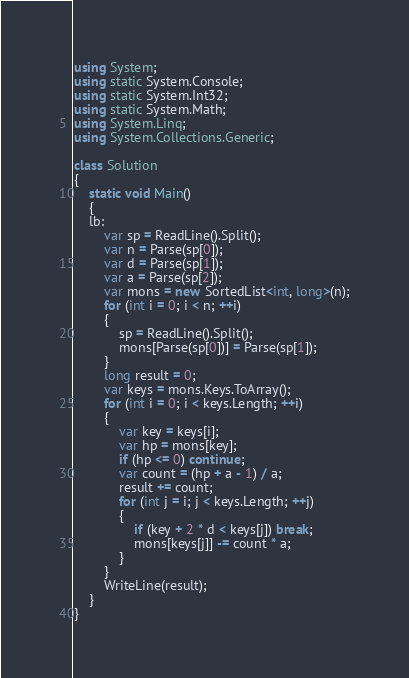<code> <loc_0><loc_0><loc_500><loc_500><_C#_>using System;
using static System.Console;
using static System.Int32;
using static System.Math;
using System.Linq;
using System.Collections.Generic;

class Solution
{
    static void Main()
    {
    lb:
        var sp = ReadLine().Split();
        var n = Parse(sp[0]);
        var d = Parse(sp[1]);
        var a = Parse(sp[2]);
        var mons = new SortedList<int, long>(n);
        for (int i = 0; i < n; ++i)
        {
            sp = ReadLine().Split();
            mons[Parse(sp[0])] = Parse(sp[1]);
        }
        long result = 0;
        var keys = mons.Keys.ToArray();
        for (int i = 0; i < keys.Length; ++i)
        {
            var key = keys[i];
            var hp = mons[key];
            if (hp <= 0) continue;
            var count = (hp + a - 1) / a;
            result += count;
            for (int j = i; j < keys.Length; ++j)
            {
                if (key + 2 * d < keys[j]) break;
                mons[keys[j]] -= count * a;
            }
        }
        WriteLine(result);
    }
}
</code> 